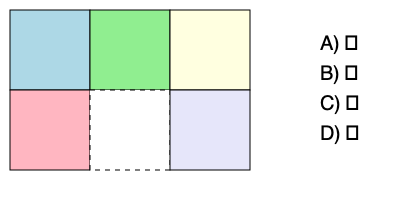Look at the jigsaw puzzle above. Which shape best fits in the empty space? Let's think about this step-by-step:

1. The puzzle is a 2x3 grid of squares.
2. Five squares are filled with different colors.
3. The empty space is in the middle of the bottom row.
4. All the other pieces are squares.
5. To complete the puzzle, we need another square to fill the empty space.
6. Looking at the options:
   A) ⬜ is a square
   B) ⬛ is a square
   C) 🔺 is a triangle
   D) ⭐ is a star
7. Only the square shapes (A or B) would fit properly in the puzzle.
8. Since the empty space has a white background, the white square (A) would be the best fit.
Answer: A) ⬜ 